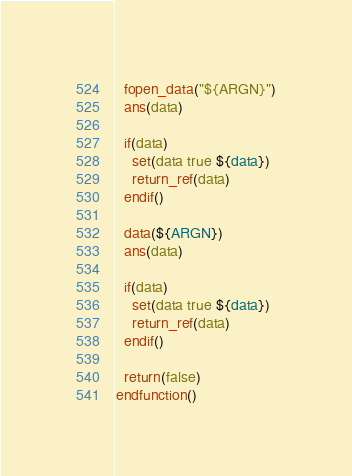<code> <loc_0><loc_0><loc_500><loc_500><_CMake_>  fopen_data("${ARGN}")
  ans(data)

  if(data)
    set(data true ${data})
    return_ref(data)
  endif()

  data(${ARGN})
  ans(data)

  if(data)
    set(data true ${data})
    return_ref(data)
  endif()

  return(false)
endfunction()</code> 